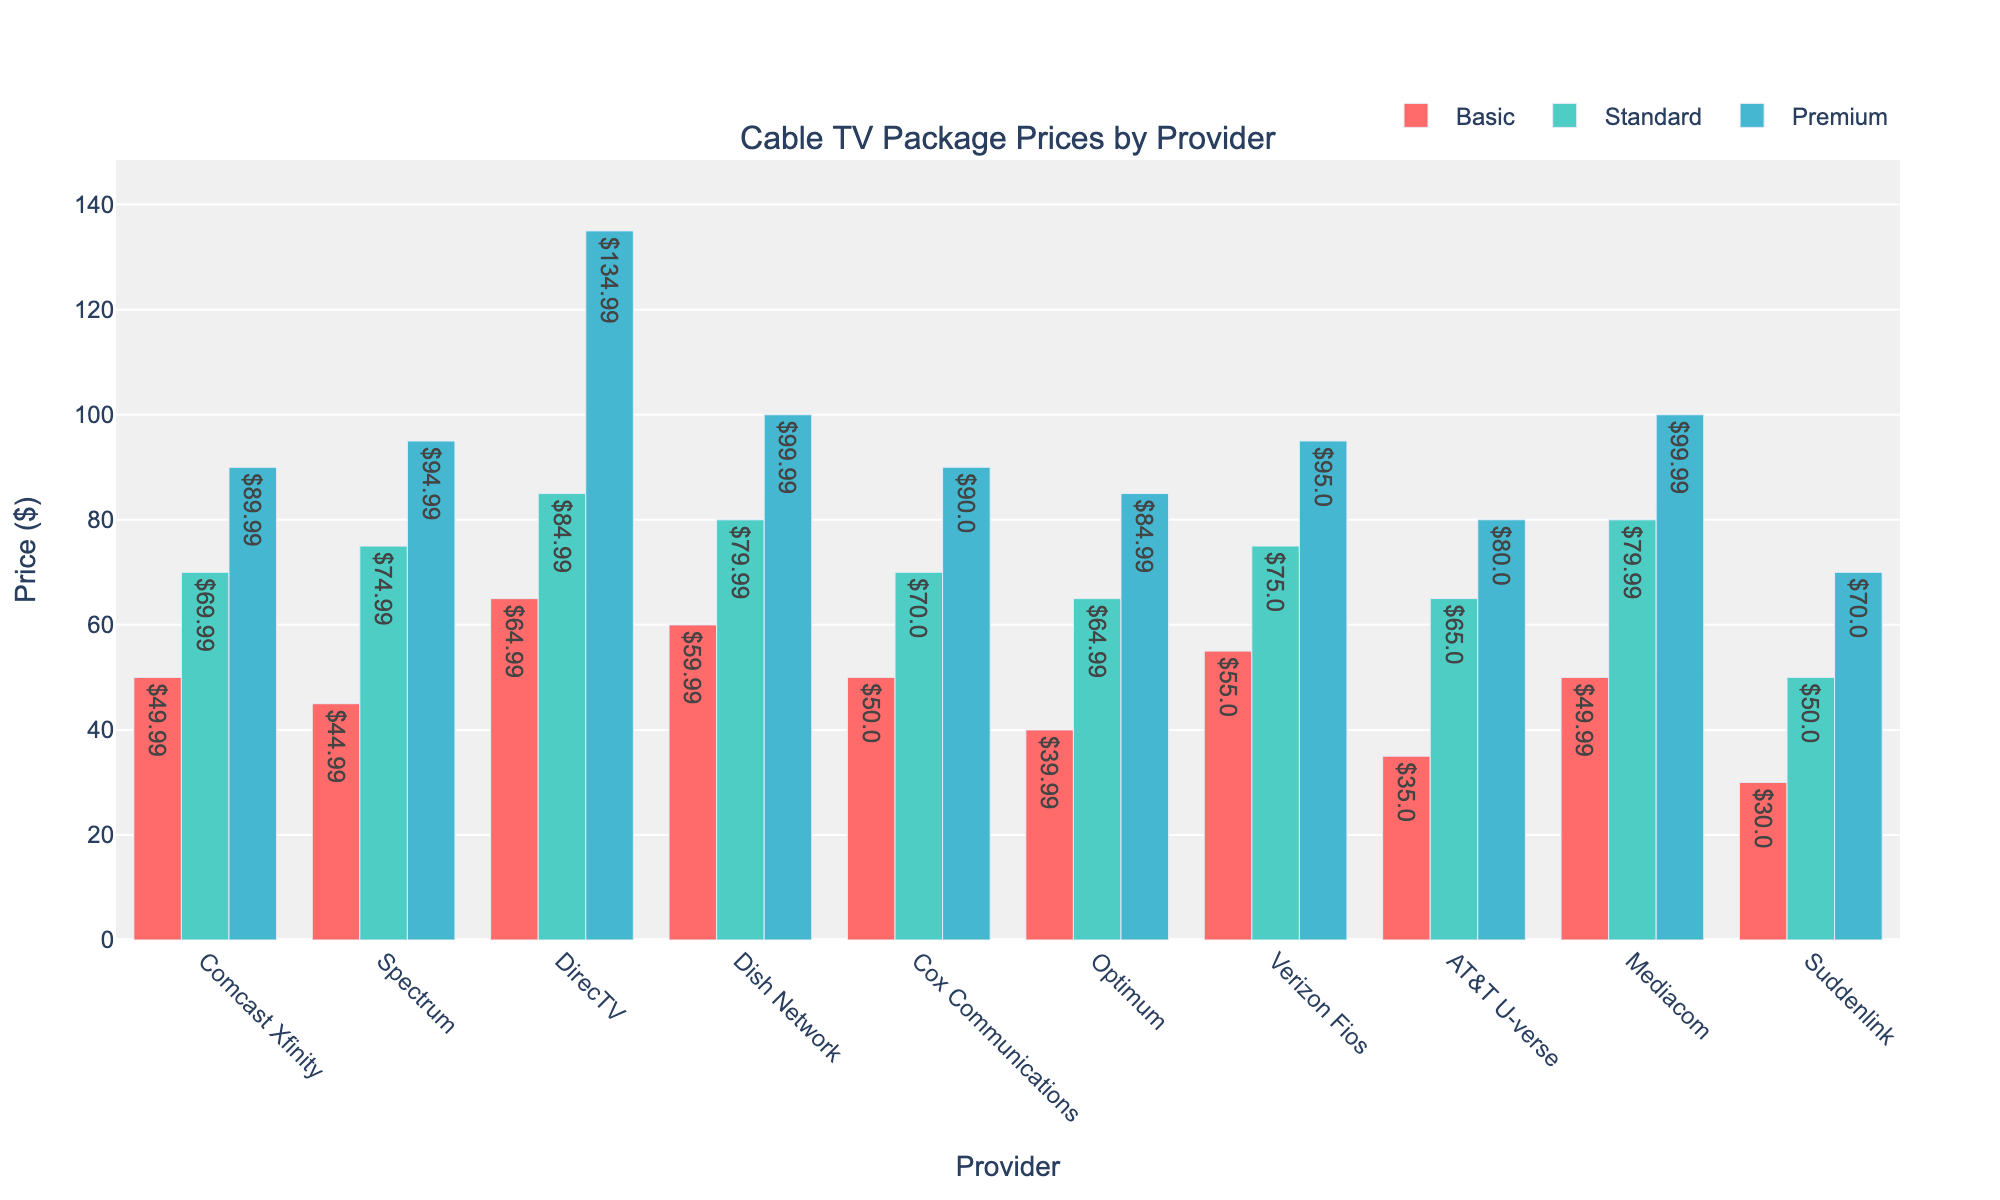Which provider has the lowest-priced basic package? Look for the shortest bar in the Basic Package Price group. Suddenlink has the lowest-priced basic package at $30.00.
Answer: Suddenlink Which provider charges the most for the premium package? Identify the tallest bar in the Premium Package Price group. DirecTV charges the most for the premium package at $134.99.
Answer: DirecTV What is the total cost for the basic and premium packages for Spectrum? Find the heights of the bars for the Basic and Premium Package Prices for Spectrum and sum them up. Spectrum's basic package is $44.99 and premium package is $94.99, so the total is $44.99 + $94.99 = $139.98.
Answer: $139.98 Which provider has the smallest difference between their basic and premium package prices? Calculate the difference between the Basic and Premium Package Prices for each provider and find the smallest difference. AT&T U-verse has the smallest difference, $80.00 - $35.00 = $45.00.
Answer: AT&T U-verse Which providers have a standard package priced at $70 or less? Look for the providers with bars in the Standard Package Price group that are $70 or less. The providers are Cox Communications, Optimum, AT&T U-verse, and Suddenlink.
Answer: Cox Communications, Optimum, AT&T U-verse, Suddenlink What is the average premium package price across all providers? Sum the heights of all bars in the Premium Package Price group and divide by the number of providers. ($89.99 + $94.99 + $134.99 + $99.99 + $90.00 + $84.99 + $95.00 + $80.00 + $99.99 + $70.00) / 10 = $93.29.
Answer: $93.29 Compare the basic package price of Comcast Xfinity and Verizon Fios. Which one is higher, and by how much? Find the difference between the heights of the bars for the Basic Package Price group for Comcast Xfinity and Verizon Fios. $55.00 (Verizon Fios) - $49.99 (Comcast Xfinity) = $5.01. Verizon Fios is higher by $5.01.
Answer: Verizon Fios, $5.01 What is the price range for the standard packages offered by each provider? Identify the highest and lowest prices for the standard packages. The range is from Suddenlink's $50.00 to DirecTV's $84.99, so the range is $84.99 - $50.00 = $34.99.
Answer: $34.99 Which provider offers the most consistent pricing across all three packages? Look for the provider with the least variation in bar heights across all three package prices. Cox Communications has prices of $50.00, $70.00, and $90.00, showing a consistent $20 increment.
Answer: Cox Communications Which provider has a higher standard package price than its premium package price? Check if any provider's Standard Package Price bar is taller than its Premium Package Price bar. None of the providers have a higher standard package price than their premium package price.
Answer: None 